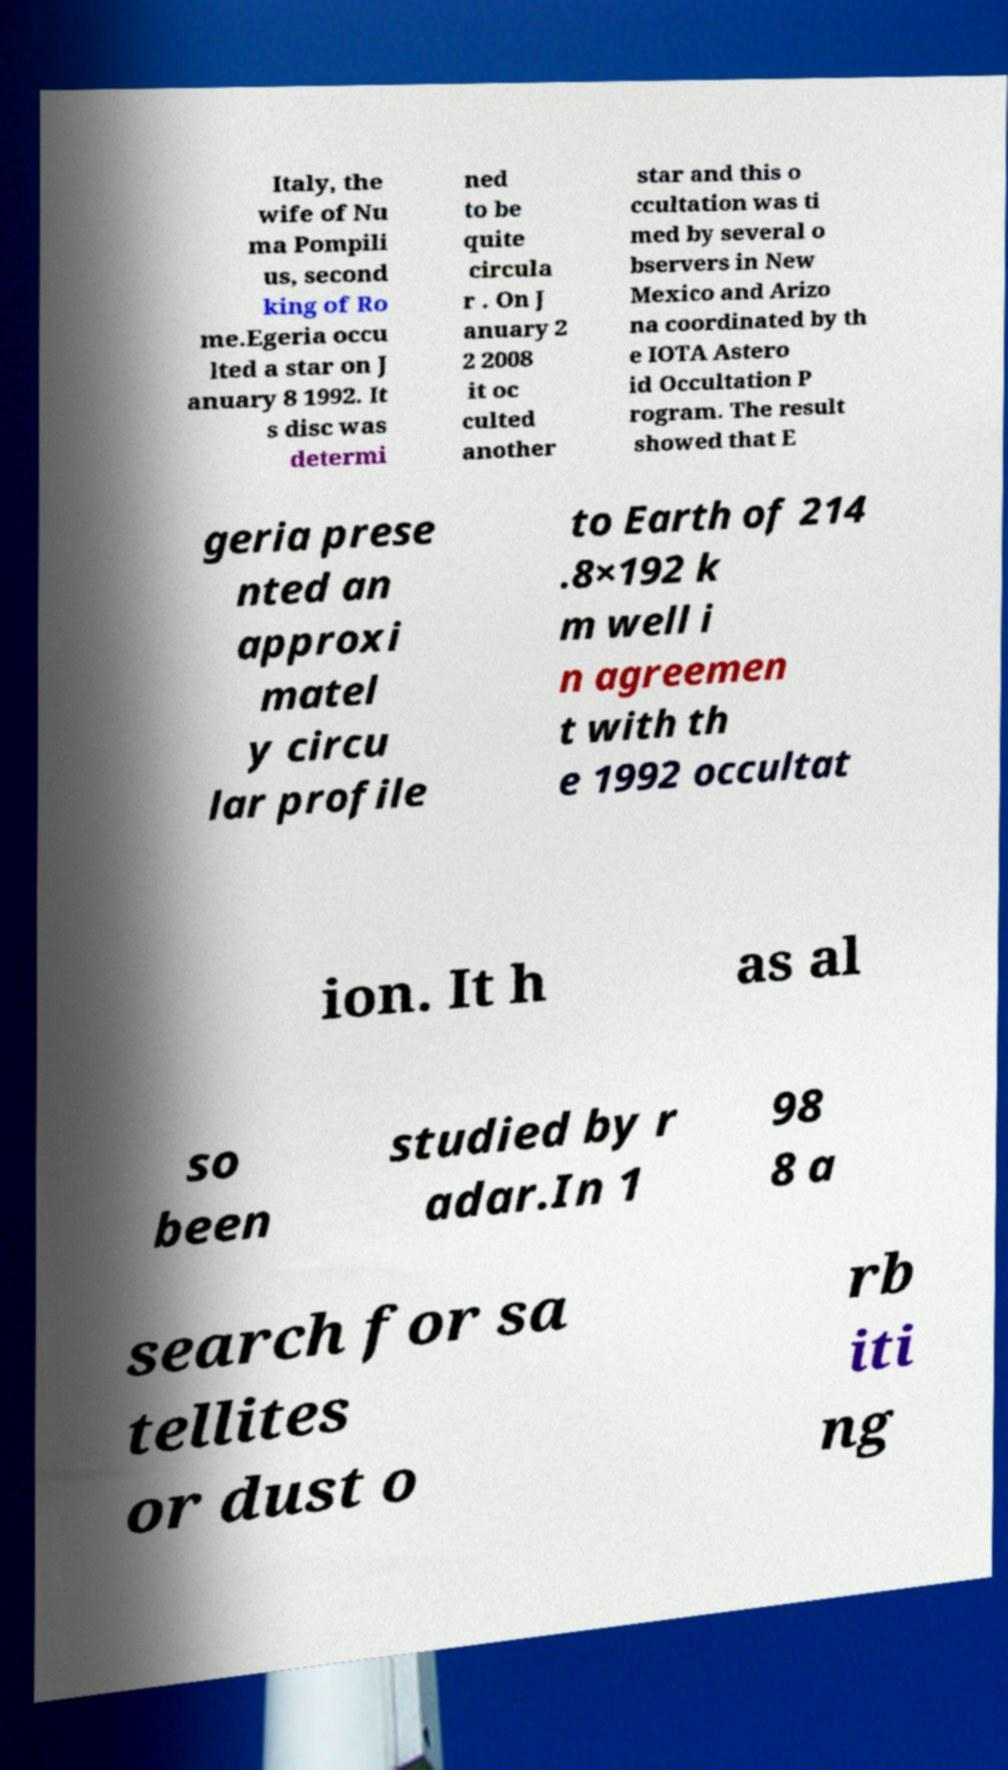Can you read and provide the text displayed in the image?This photo seems to have some interesting text. Can you extract and type it out for me? Italy, the wife of Nu ma Pompili us, second king of Ro me.Egeria occu lted a star on J anuary 8 1992. It s disc was determi ned to be quite circula r . On J anuary 2 2 2008 it oc culted another star and this o ccultation was ti med by several o bservers in New Mexico and Arizo na coordinated by th e IOTA Astero id Occultation P rogram. The result showed that E geria prese nted an approxi matel y circu lar profile to Earth of 214 .8×192 k m well i n agreemen t with th e 1992 occultat ion. It h as al so been studied by r adar.In 1 98 8 a search for sa tellites or dust o rb iti ng 